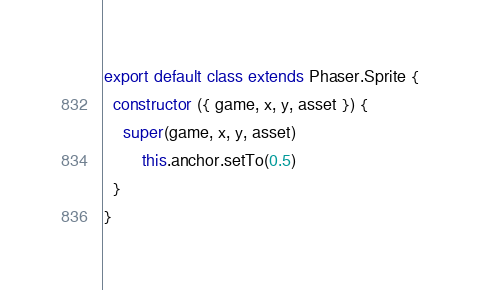<code> <loc_0><loc_0><loc_500><loc_500><_JavaScript_>export default class extends Phaser.Sprite {
  constructor ({ game, x, y, asset }) {
    super(game, x, y, asset)
		this.anchor.setTo(0.5)
  }
}
</code> 